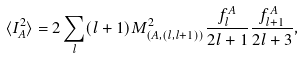<formula> <loc_0><loc_0><loc_500><loc_500>\langle I _ { A } ^ { 2 } \rangle = 2 \sum _ { l } ( l + 1 ) M ^ { 2 } _ { \left ( A , \left ( l , l + 1 \right ) \right ) } \frac { f ^ { A } _ { l } } { 2 l + 1 } \frac { f ^ { A } _ { l + 1 } } { 2 l + 3 } ,</formula> 